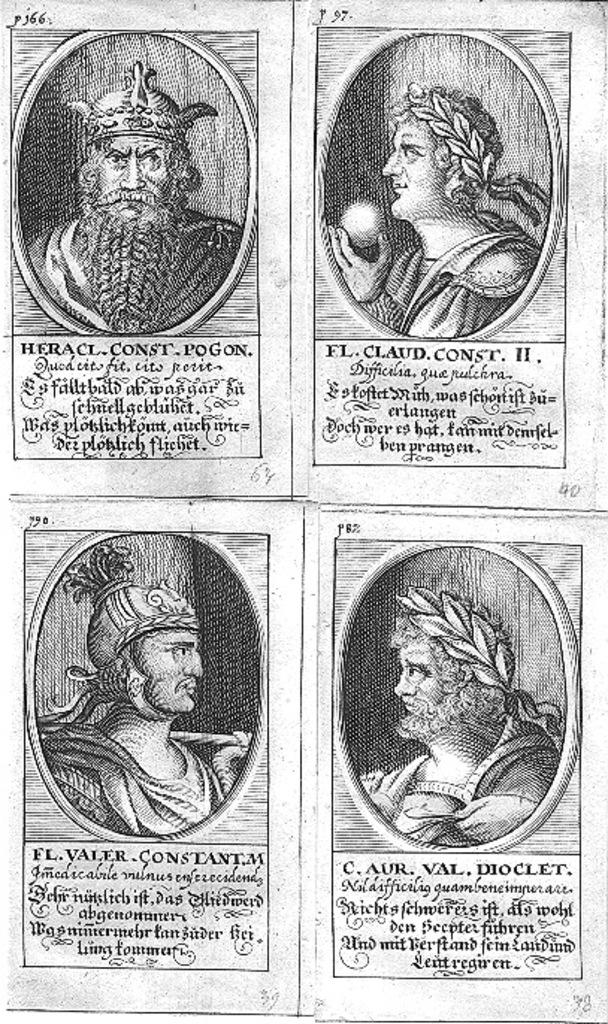What can be seen in the image? There are photos and a paper with letters written on it in the image. Can you describe the paper with letters in more detail? The paper with letters written on it is visible in the image. What type of balloon is floating in space in the image? There is no balloon or space present in the image; it only features photos and a paper with letters written on it. 